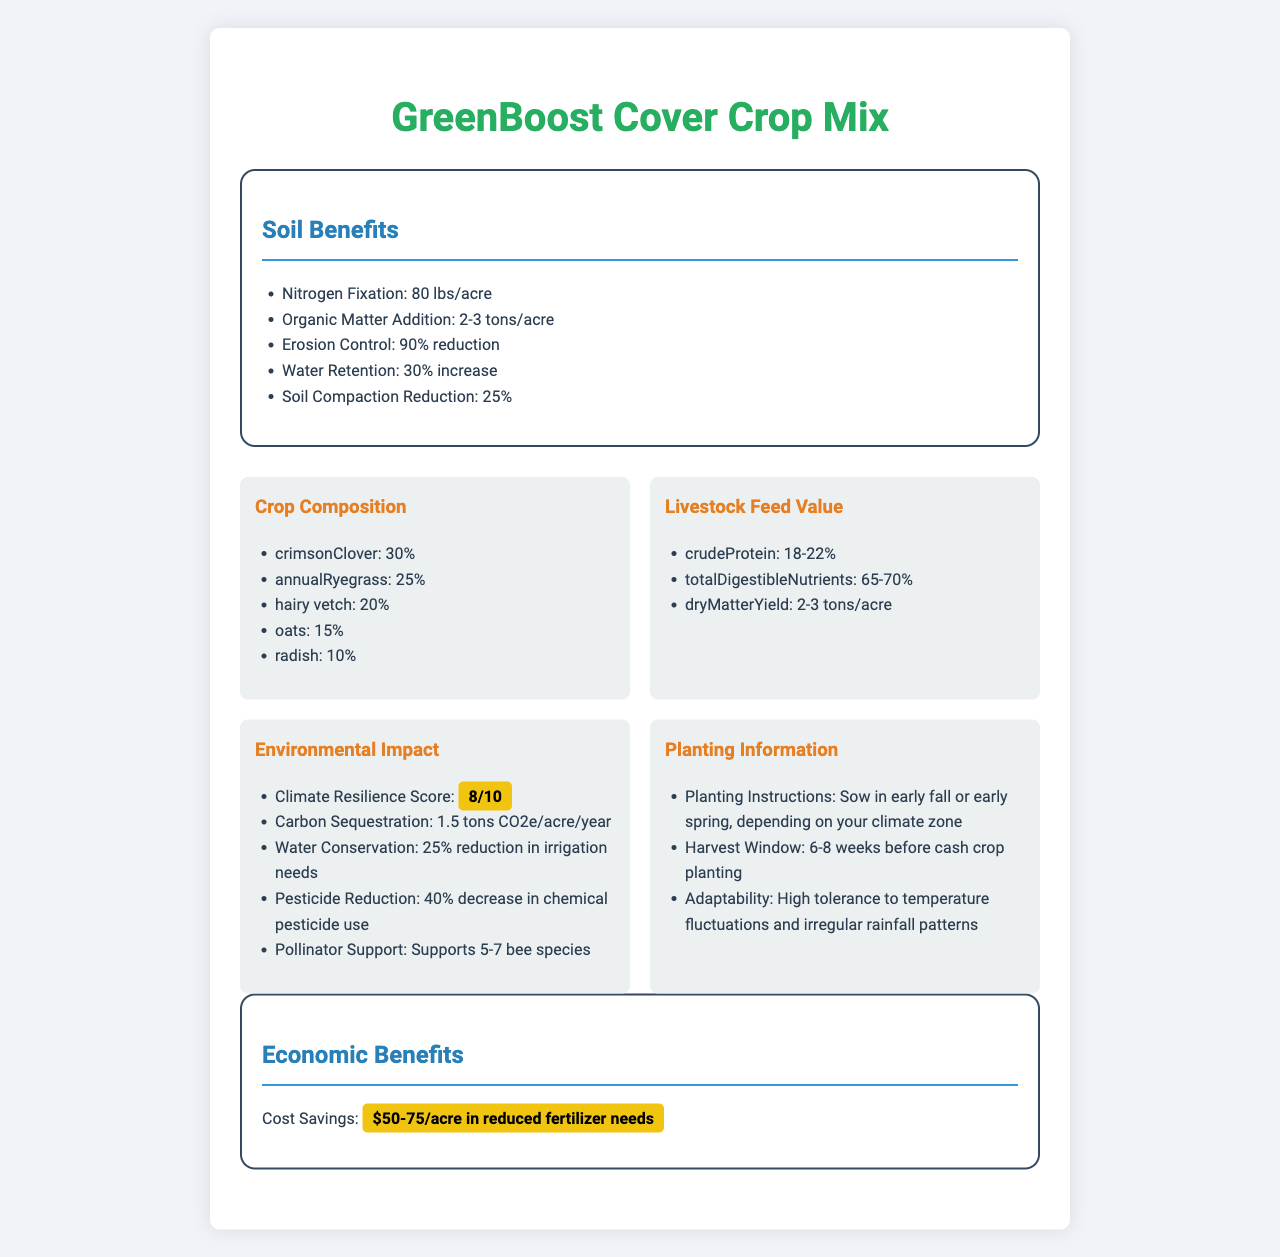- What is the nitrogen fixation rate for the GreenBoost Cover Crop Mix? The document lists the nitrogen fixation as 80 lbs/acre in the Soil Benefits section.
Answer: 80 lbs/acre - How much organic matter addition per acre does the mix provide? The document indicates an organic matter addition of 2-3 tons/acre under the Soil Benefits section.
Answer: 2-3 tons/acre - What percentage of crimson clover is in the crop composition? The Crop Composition section states that crimson clover makes up 30% of the mix.
Answer: 30% - What is the climate resilience score of the GreenBoost Cover Crop Mix? The Environmental Impact section lists the Climate Resilience Score as 8/10.
Answer: 8/10 - How long should one wait before planting a cash crop after using the cover crop mix? The Planting Information section specifies a harvest window of 6-8 weeks before the cash crop planting.
Answer: 6-8 weeks - Which of the following is part of the crop composition? A. Sunflower B. Crimson Clover C. Barley The document lists crimson clover as 30% of the crop composition; sunflower and barley are not mentioned.
Answer: B. Crimson Clover - What is the suggested time frame for sowing the cover crop mix? A. Late Spring B. Early Fall or Early Spring C. Mid-Summer The document suggests sowing in early fall or early spring, as noted in the Planting Information section.
Answer: B. Early Fall or Early Spring - Does the GreenBoost Cover Crop Mix reduce the need for chemical pesticides by more than 30%? The Environmental Impact section mentions a 40% decrease in chemical pesticide use, which is more than 30%.
Answer: Yes - What is the primary purpose of the document? The document is a comprehensive overview designed to explain the benefits and instructions for using the GreenBoost Cover Crop Mix.
Answer: The document provides detailed information about the GreenBoost Cover Crop Mix, including its soil benefits, crop composition, livestock feed value, environmental impact, planting instructions, and economic benefits. - How much calcium does the GreenBoost Cover Crop Mix provide? The document does not provide any information on the calcium content of the mix; it lists calcium as N/A (Not Available).
Answer: Not enough information - How much does the cover crop mix contribute to water conservation? The Environmental Impact section indicates a 25% reduction in irrigation needs due to the water conservation properties of the cover crop mix.
Answer: 25% reduction in irrigation needs 